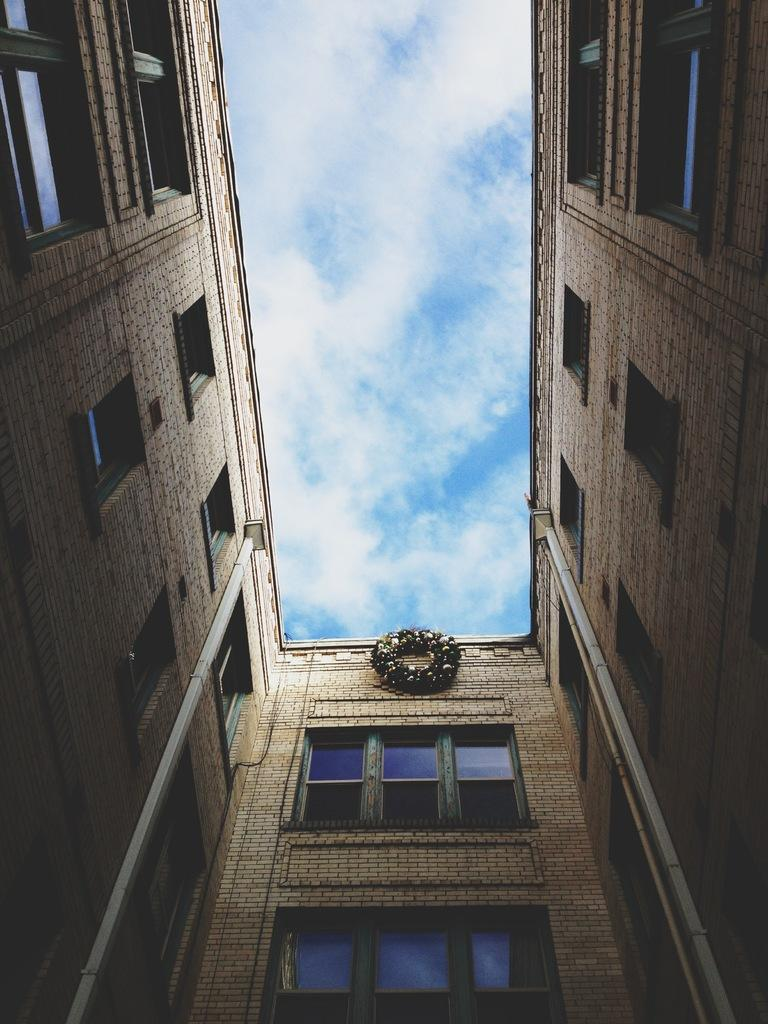What is the main structure in the image? There is a building in the image. What feature of the building is mentioned in the facts? The building has multiple windows. What can be seen in the background of the image? There are clouds and the sky visible in the background of the image. What is the building's desire to explore the trail in the image? Buildings do not have desires, as they are inanimate objects. There is no trail present in the image. 